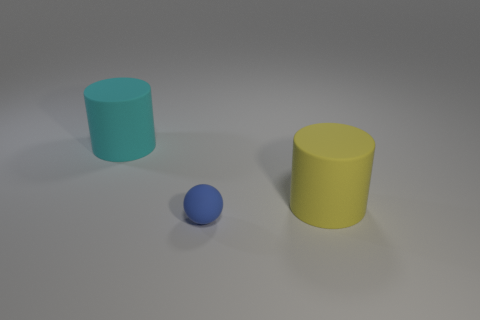Add 3 tiny cyan rubber balls. How many objects exist? 6 Subtract all cylinders. How many objects are left? 1 Subtract all cyan matte things. Subtract all tiny rubber things. How many objects are left? 1 Add 3 large cyan rubber objects. How many large cyan rubber objects are left? 4 Add 1 large gray cylinders. How many large gray cylinders exist? 1 Subtract 0 green blocks. How many objects are left? 3 